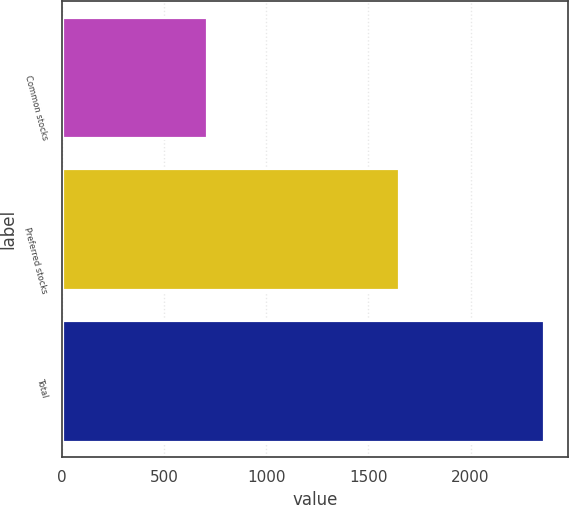Convert chart to OTSL. <chart><loc_0><loc_0><loc_500><loc_500><bar_chart><fcel>Common stocks<fcel>Preferred stocks<fcel>Total<nl><fcel>707<fcel>1651<fcel>2358<nl></chart> 